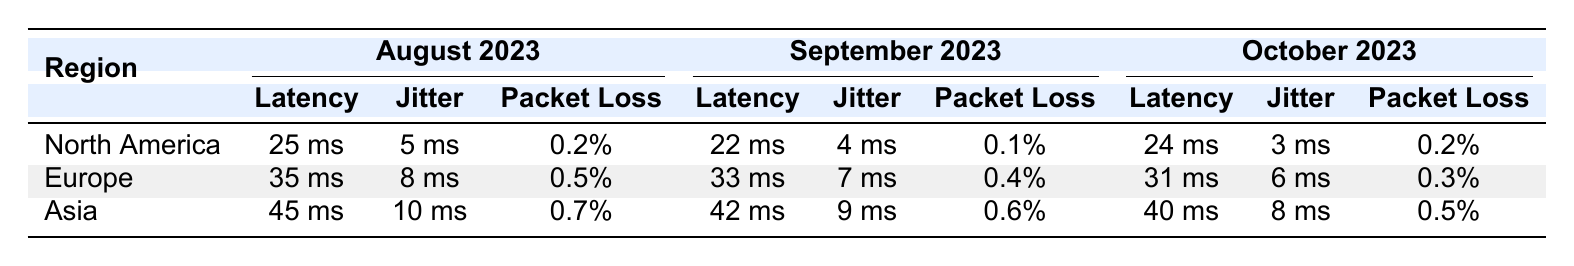What is the latency in North America for August 2023? The table shows that the latency for North America in August 2023 is 25 ms.
Answer: 25 ms What is the packet loss percentage for Europe in September 2023? The table indicates a packet loss of 0.4% for Europe in September 2023.
Answer: 0.4% What was the average jitter across all regions in October 2023? The jittter values for October 2023 are: North America (3 ms), Europe (6 ms), and Asia (8 ms). The average jitter is (3 + 6 + 8)/3 = 5.67 ms.
Answer: 5.67 ms Was the latency in Asia higher than that in North America for September 2023? In September 2023, Asia had a latency of 42 ms while North America had a latency of 22 ms. Thus, Asia's latency was higher.
Answer: Yes What is the difference in latency between Europe and Asia for August 2023? For August 2023, Europe had a latency of 35 ms and Asia had 45 ms. The difference is 45 - 35 = 10 ms.
Answer: 10 ms Did North America experience a decrease in packet loss from August to September 2023? North America's packet loss was 0.2% in August and decreased to 0.1% in September. Therefore, it experienced a decrease.
Answer: Yes Which region had the highest latency in October 2023? In October 2023, Asia had a latency of 40 ms, which is higher than North America's 24 ms and Europe's 31 ms. Thus, Asia had the highest latency.
Answer: Asia What was the total packet loss across all regions in August 2023? The packet loss for August 2023 is: North America (0.2%), Europe (0.5%), and Asia (0.7%). The total is 0.2 + 0.5 + 0.7 = 1.4%.
Answer: 1.4% Did Europe show improvement in latency from September to October 2023? September 2023 latency for Europe was 33 ms and in October it was 31 ms. This indicates an improvement in latency.
Answer: Yes What was the highest packet loss in September 2023 across all regions? The packet loss values for September 2023 are: North America (0.1%), Europe (0.4%), and Asia (0.6%). The highest is from Asia at 0.6%.
Answer: 0.6% 